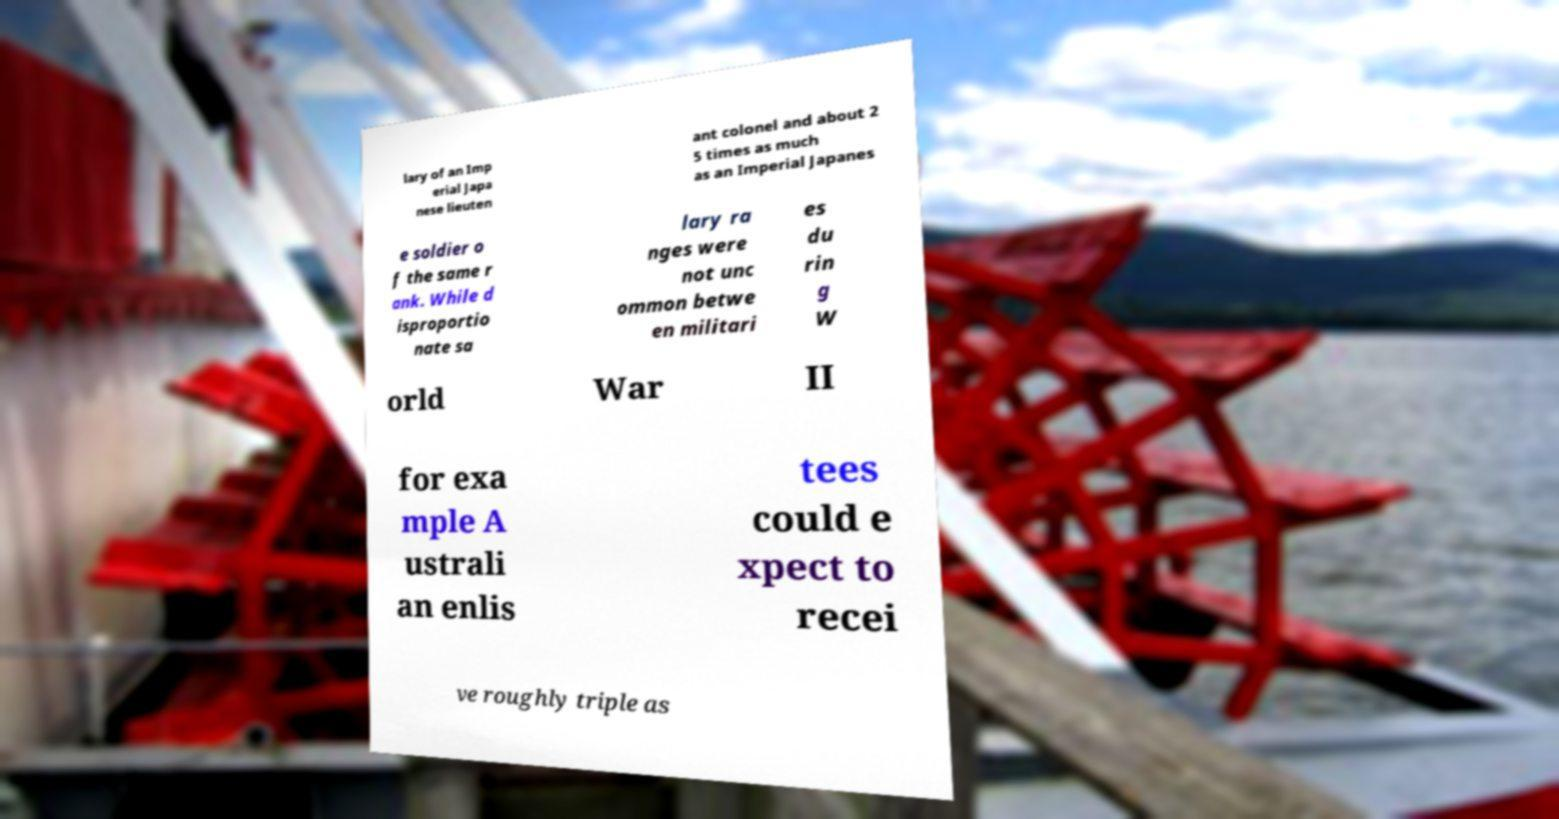Can you accurately transcribe the text from the provided image for me? lary of an Imp erial Japa nese lieuten ant colonel and about 2 5 times as much as an Imperial Japanes e soldier o f the same r ank. While d isproportio nate sa lary ra nges were not unc ommon betwe en militari es du rin g W orld War II for exa mple A ustrali an enlis tees could e xpect to recei ve roughly triple as 